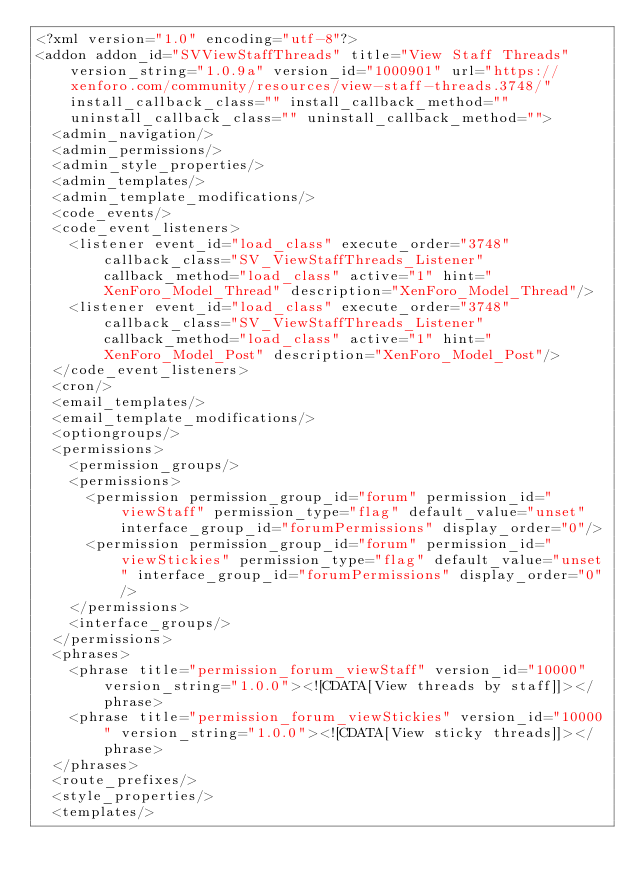<code> <loc_0><loc_0><loc_500><loc_500><_XML_><?xml version="1.0" encoding="utf-8"?>
<addon addon_id="SVViewStaffThreads" title="View Staff Threads" version_string="1.0.9a" version_id="1000901" url="https://xenforo.com/community/resources/view-staff-threads.3748/" install_callback_class="" install_callback_method="" uninstall_callback_class="" uninstall_callback_method="">
  <admin_navigation/>
  <admin_permissions/>
  <admin_style_properties/>
  <admin_templates/>
  <admin_template_modifications/>
  <code_events/>
  <code_event_listeners>
    <listener event_id="load_class" execute_order="3748" callback_class="SV_ViewStaffThreads_Listener" callback_method="load_class" active="1" hint="XenForo_Model_Thread" description="XenForo_Model_Thread"/>
    <listener event_id="load_class" execute_order="3748" callback_class="SV_ViewStaffThreads_Listener" callback_method="load_class" active="1" hint="XenForo_Model_Post" description="XenForo_Model_Post"/>
  </code_event_listeners>
  <cron/>
  <email_templates/>
  <email_template_modifications/>
  <optiongroups/>
  <permissions>
    <permission_groups/>
    <permissions>
      <permission permission_group_id="forum" permission_id="viewStaff" permission_type="flag" default_value="unset" interface_group_id="forumPermissions" display_order="0"/>
      <permission permission_group_id="forum" permission_id="viewStickies" permission_type="flag" default_value="unset" interface_group_id="forumPermissions" display_order="0"/>
    </permissions>
    <interface_groups/>
  </permissions>
  <phrases>
    <phrase title="permission_forum_viewStaff" version_id="10000" version_string="1.0.0"><![CDATA[View threads by staff]]></phrase>
    <phrase title="permission_forum_viewStickies" version_id="10000" version_string="1.0.0"><![CDATA[View sticky threads]]></phrase>
  </phrases>
  <route_prefixes/>
  <style_properties/>
  <templates/></code> 